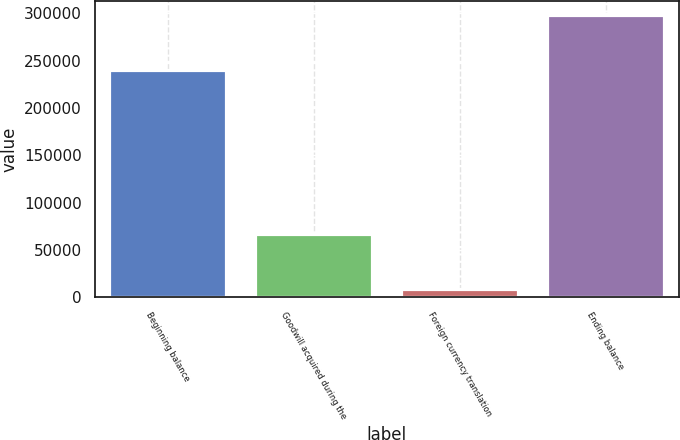<chart> <loc_0><loc_0><loc_500><loc_500><bar_chart><fcel>Beginning balance<fcel>Goodwill acquired during the<fcel>Foreign currency translation<fcel>Ending balance<nl><fcel>239626<fcel>67066<fcel>8699<fcel>297993<nl></chart> 